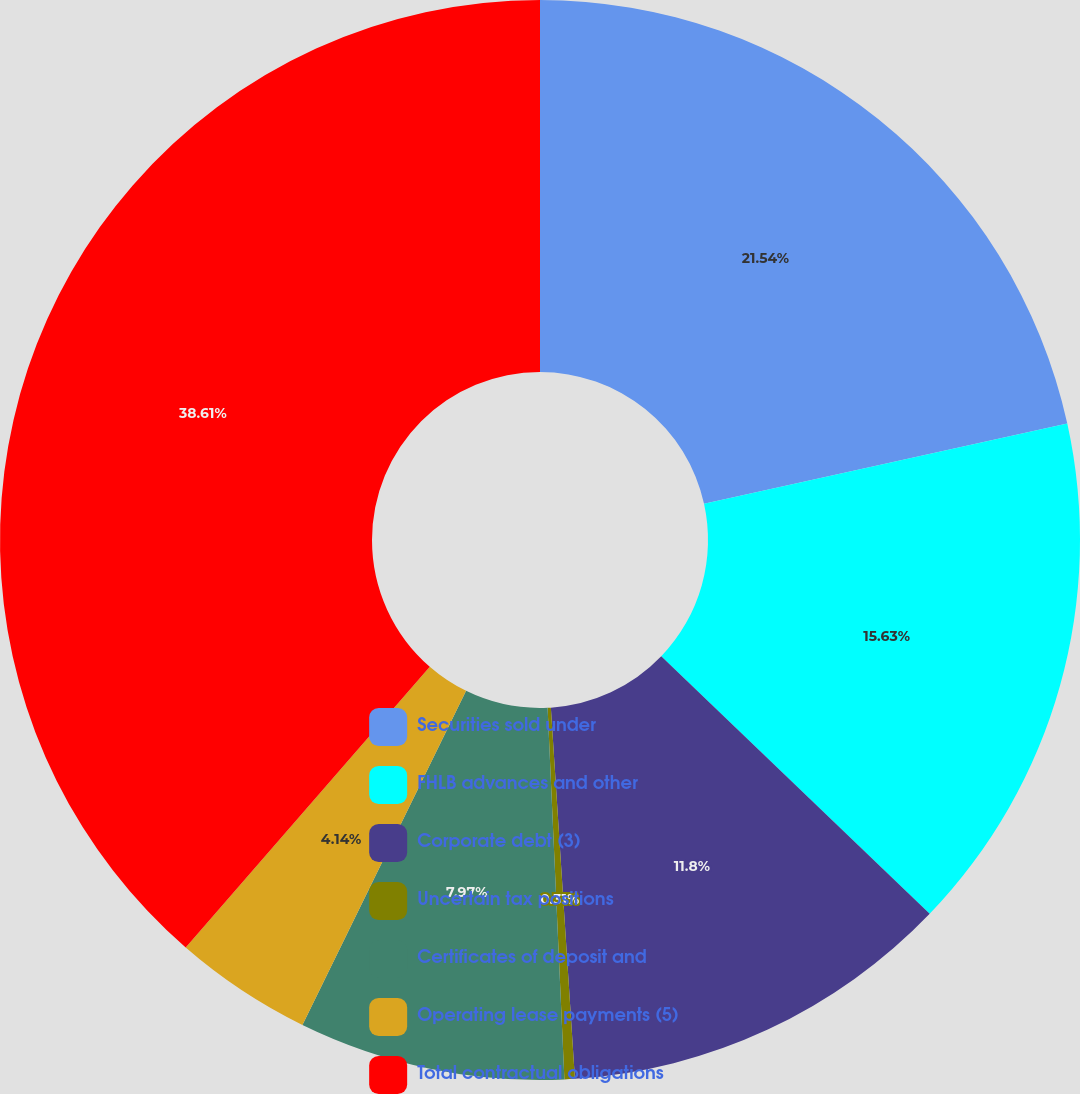Convert chart. <chart><loc_0><loc_0><loc_500><loc_500><pie_chart><fcel>Securities sold under<fcel>FHLB advances and other<fcel>Corporate debt (3)<fcel>Uncertain tax positions<fcel>Certificates of deposit and<fcel>Operating lease payments (5)<fcel>Total contractual obligations<nl><fcel>21.54%<fcel>15.63%<fcel>11.8%<fcel>0.31%<fcel>7.97%<fcel>4.14%<fcel>38.61%<nl></chart> 